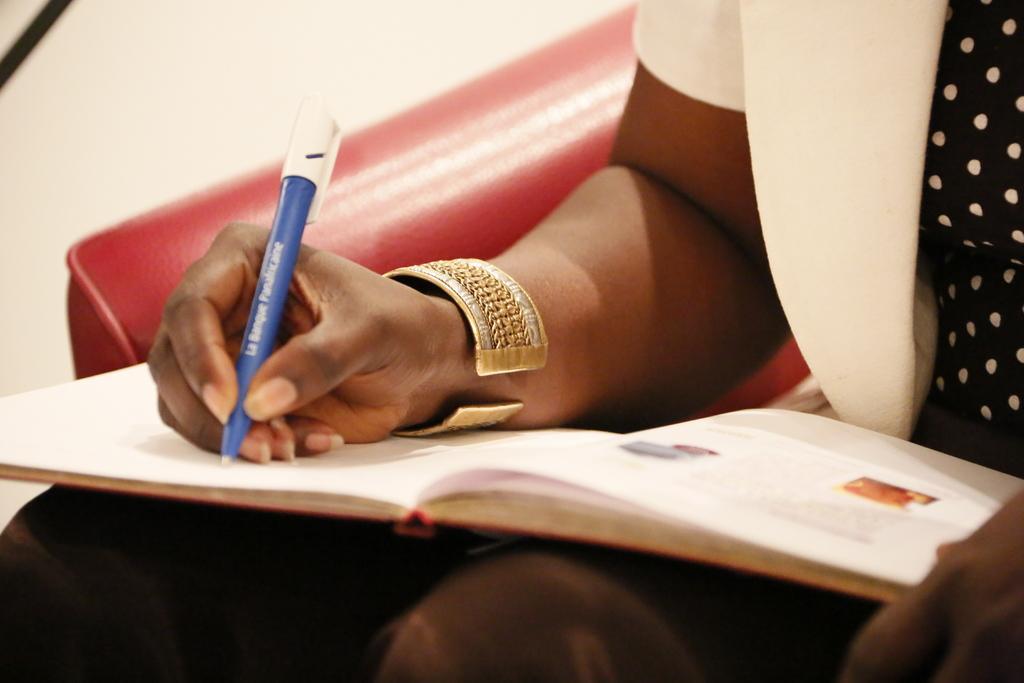Could you give a brief overview of what you see in this image? In this picture we can see a person, sitting on a red chair. We can see a person is holding a pen and writing something. We can see a book. 